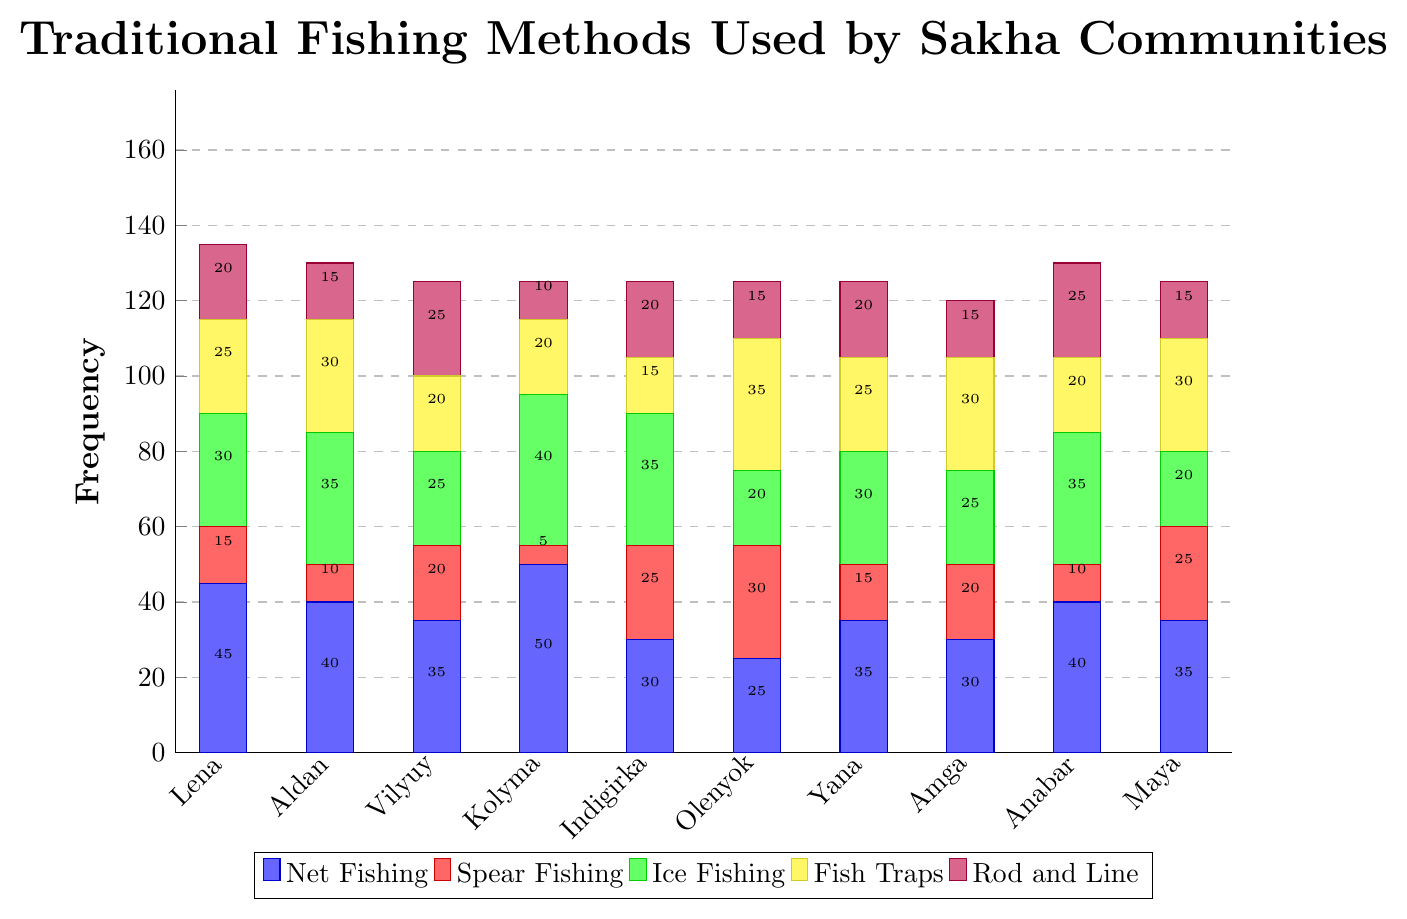Which river has the highest frequency of Net Fishing? By looking at the height of the blue bars for each river, the highest bar corresponds to the Kolyma River.
Answer: Kolyma What is the total frequency of Ice Fishing across all rivers? We need to add up the frequencies of Ice Fishing (green bars) for all rivers: 30 + 35 + 25 + 40 + 35 + 20 + 30 + 25 + 35 + 20 = 295.
Answer: 295 Which fishing method is least frequently used on the Yana River? By looking at the bars for the Yana River, the shortest bar corresponds to Spear Fishing (red).
Answer: Spear Fishing Compare the frequency of Fish Traps between the Olenyok and Maya rivers and state which is higher. Fish Traps are represented by yellow bars. Olenyok's yellow bar is at 35 and Maya's is at 30, so Olenyok's frequency is higher.
Answer: Olenyok What is the combined frequency of Spear Fishing and Ice Fishing on the Indigirka River? Add the heights of red and green bars for the Indigirka River: 25 (red) + 35 (green) = 60.
Answer: 60 Which river has the largest variety of traditional fishing methods used almost equally? Look for the river where all the bars are somewhat similar in height. Maya has bars relatively equal in height for all fishing methods.
Answer: Maya On which river system is Rod and Line fishing most frequently used? Look for the tallest purple bar among the rivers. The Vilyuy and Anabar Rivers both have the highest Rod and Line frequency at 25, but Vilyuy appears first.
Answer: Vilyuy What is the difference in frequency of Net Fishing between the Lena and Indigirka rivers? Subtract the frequency of Net Fishing of Indigirka from Lena: 45 (Lena) - 30 (Indigirka) = 15.
Answer: 15 Which fishing method shows the most consistent usage across all rivers? Look at the consistency in bar heights across all rivers. Fish Traps (yellow) vary less compared to other fishing methods.
Answer: Fish Traps What is the average frequency of Spear Fishing across the Kolyma and Olenyok rivers? Add the Spear Fishing frequencies for Kolyma and Olenyok and divide by 2: (5 + 30) / 2 = 17.5.
Answer: 17.5 